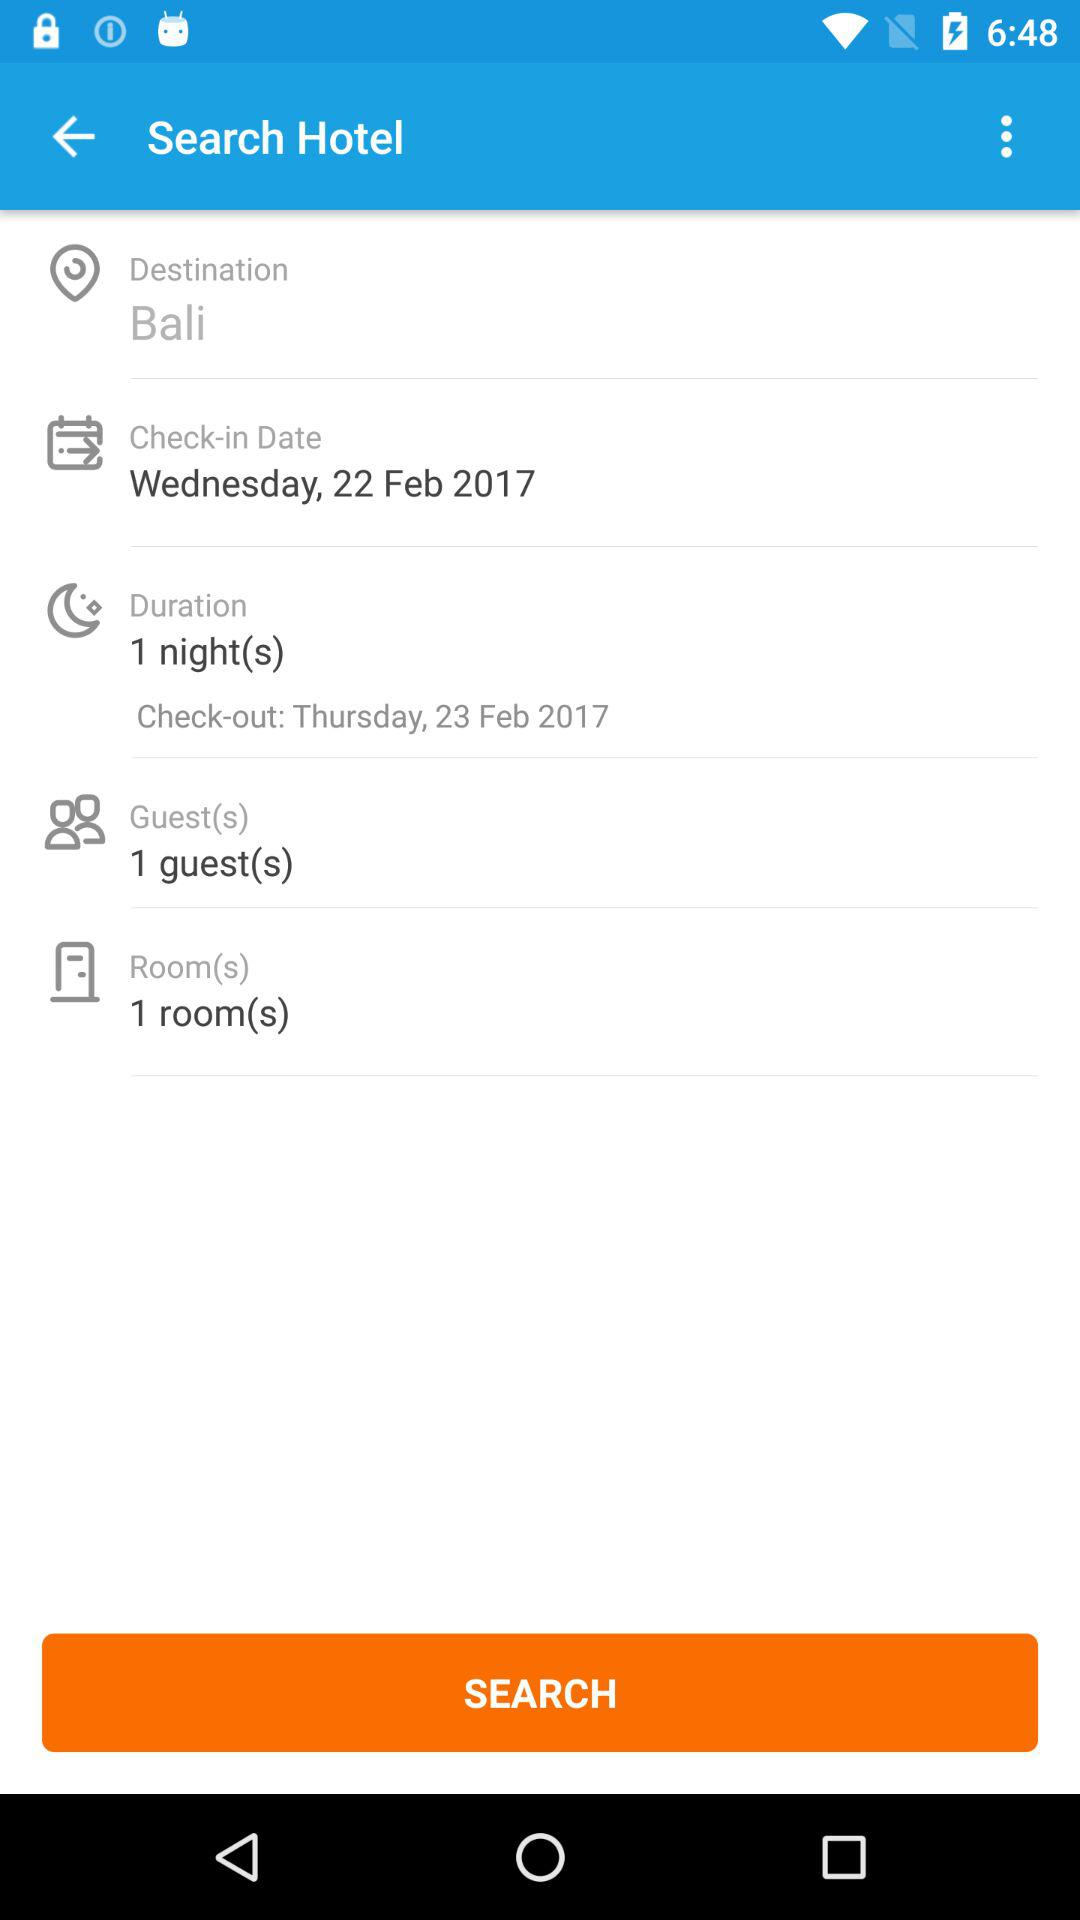What is the destination? The destination is Bali. 